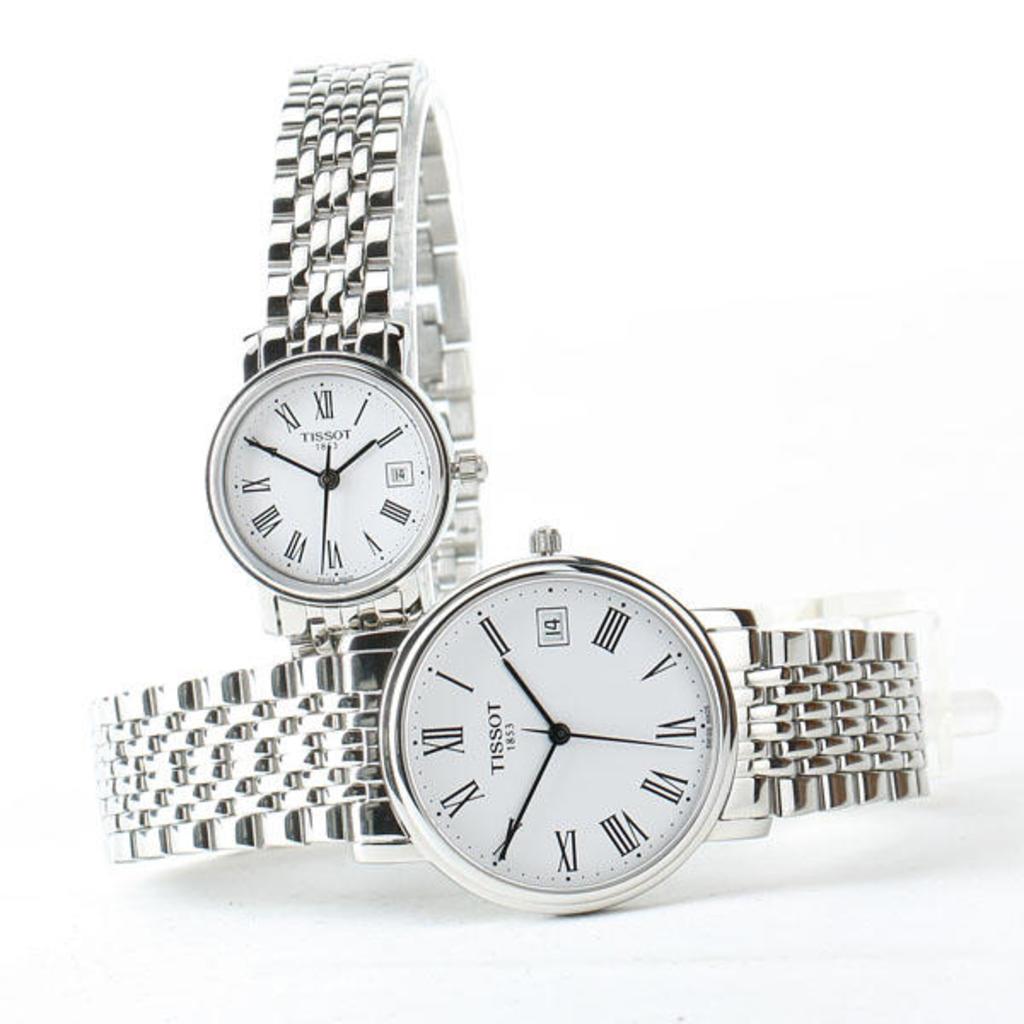What time is on the watch?
Offer a very short reply. 1:50. What time is shown on the watch?
Provide a succinct answer. 1:50. 